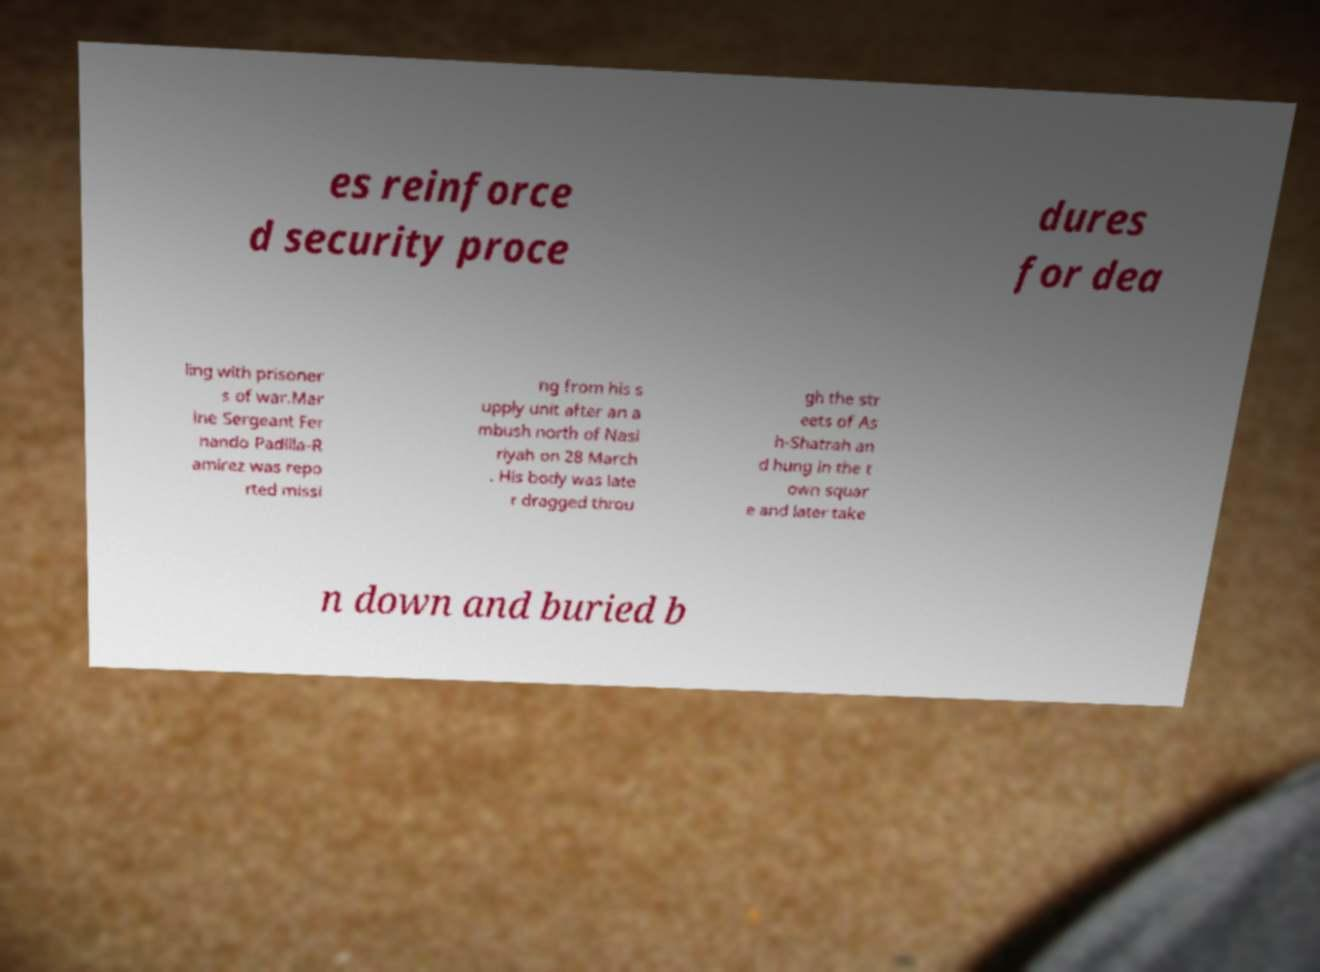Please read and relay the text visible in this image. What does it say? es reinforce d security proce dures for dea ling with prisoner s of war.Mar ine Sergeant Fer nando Padilla-R amirez was repo rted missi ng from his s upply unit after an a mbush north of Nasi riyah on 28 March . His body was late r dragged throu gh the str eets of As h-Shatrah an d hung in the t own squar e and later take n down and buried b 